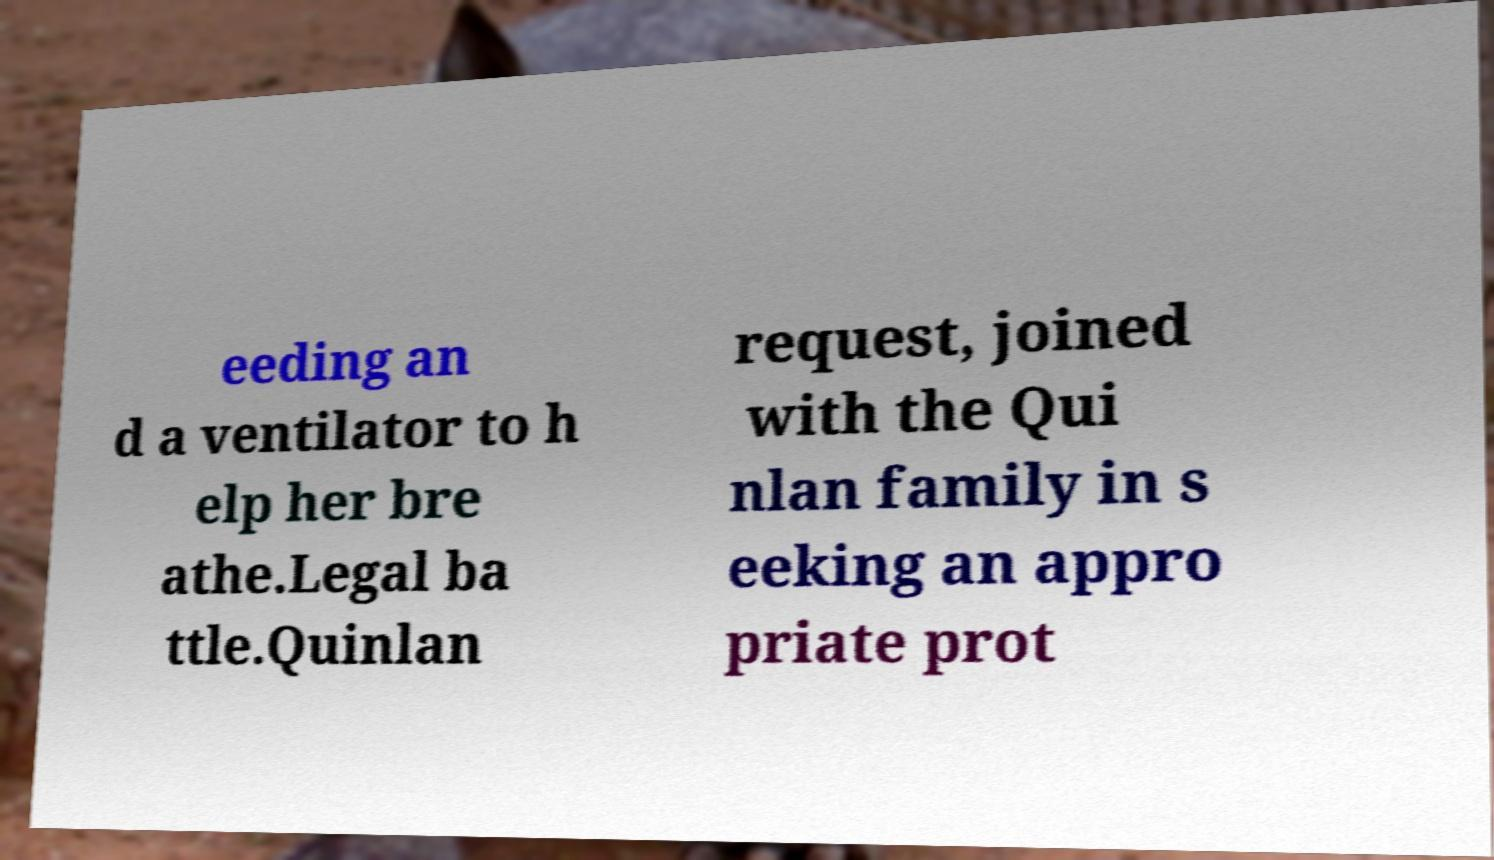Can you accurately transcribe the text from the provided image for me? eeding an d a ventilator to h elp her bre athe.Legal ba ttle.Quinlan request, joined with the Qui nlan family in s eeking an appro priate prot 